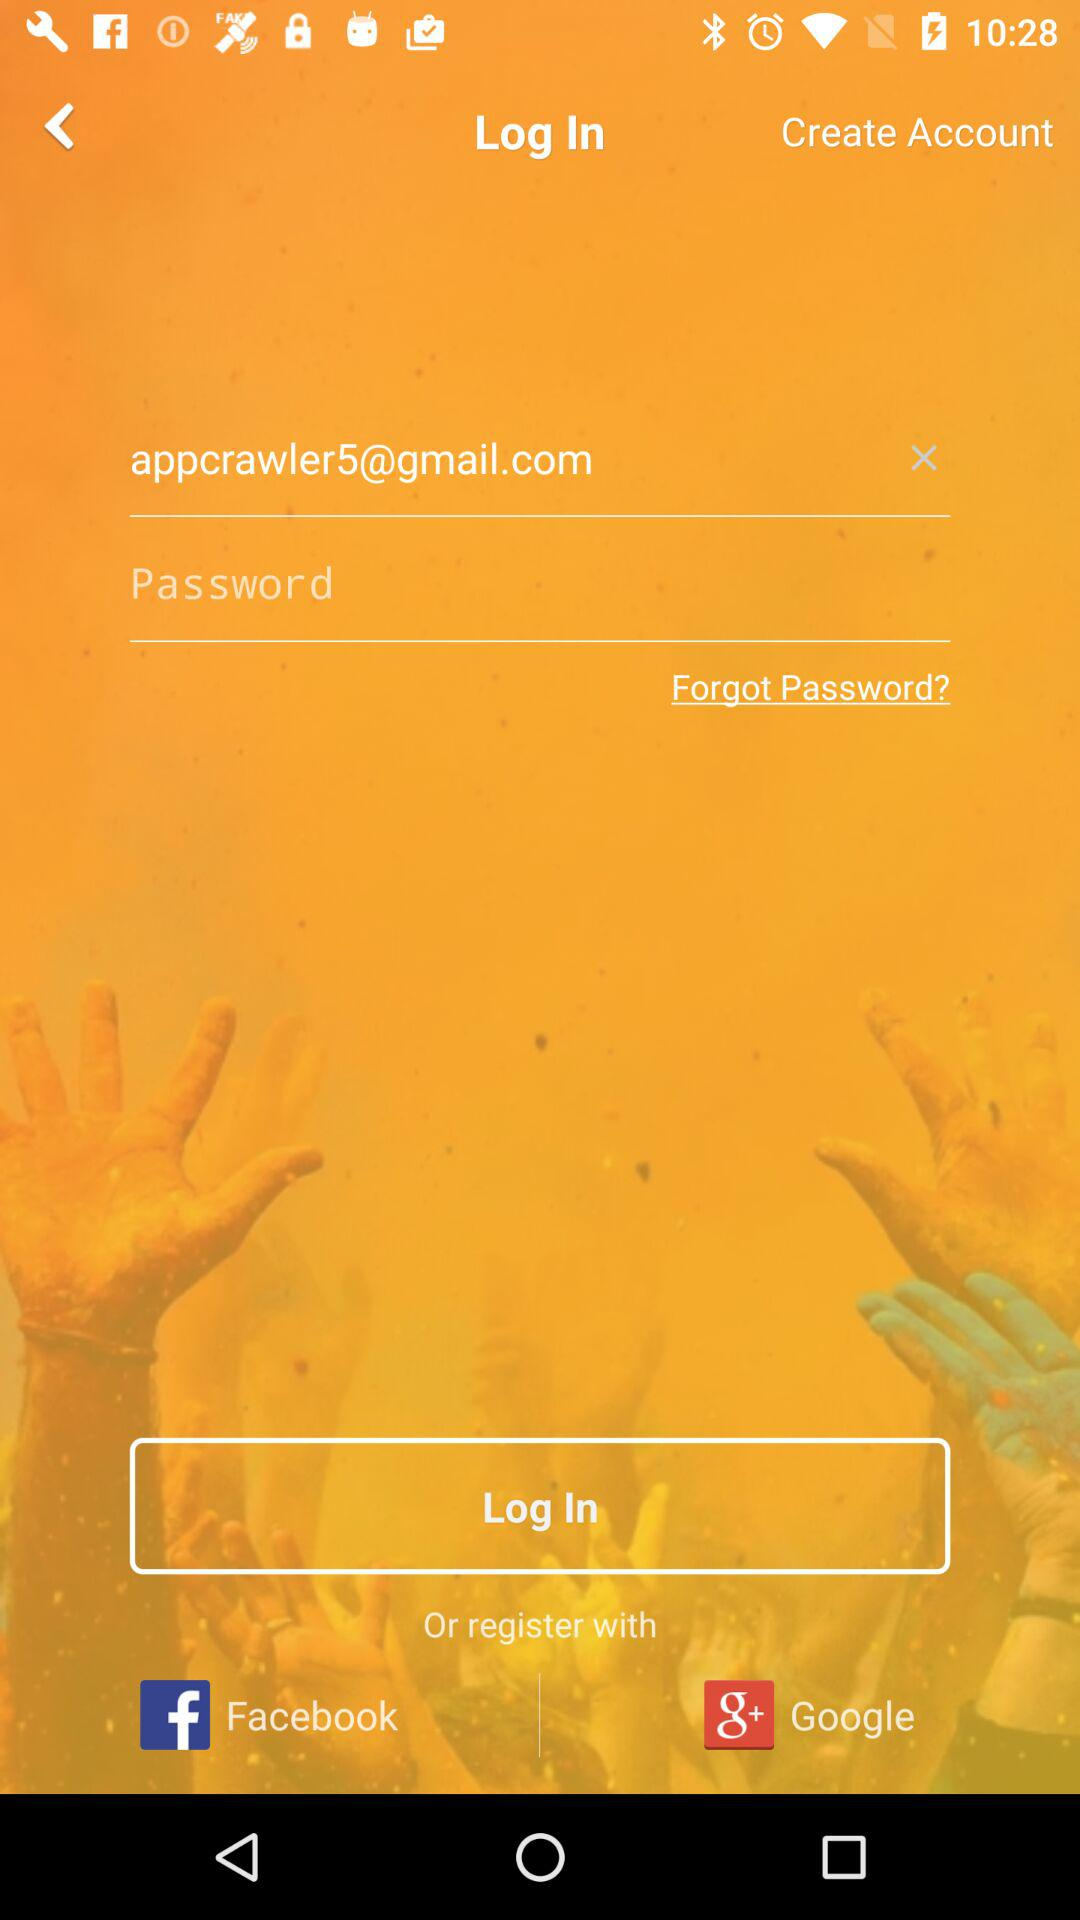How many text fields are there?
Answer the question using a single word or phrase. 2 